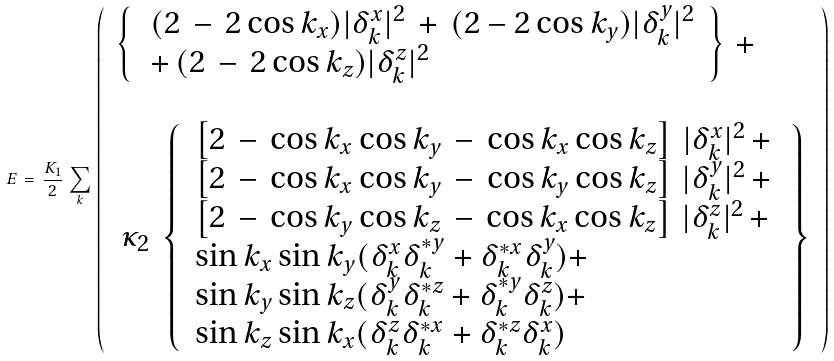Convert formula to latex. <formula><loc_0><loc_0><loc_500><loc_500>E \, = \, \frac { K _ { 1 } } { 2 } \, \sum _ { k } \, \left ( \, \begin{array} { l } \left \{ \, \begin{array} { l } \, ( 2 \, - \, 2 \cos k _ { x } ) | \delta _ { k } ^ { x } | ^ { 2 } \, + \, ( 2 - 2 \cos k _ { y } ) | \delta _ { k } ^ { y } | ^ { 2 } \\ \, + \, ( 2 \, - \, 2 \cos k _ { z } ) | \delta _ { k } ^ { z } | ^ { 2 } \end{array} \, \right \} \, + \, \\ \\ \, \kappa _ { 2 } \, \left \{ \, \begin{array} { l } \left [ 2 \, - \, \cos k _ { x } \cos k _ { y } \, - \, \cos k _ { x } \cos k _ { z } \right ] \, | \delta _ { k } ^ { x } | ^ { 2 } \, + \, \\ \left [ 2 \, - \, \cos k _ { x } \cos k _ { y } \, - \, \cos k _ { y } \cos k _ { z } \right ] \, | \delta _ { k } ^ { y } | ^ { 2 } \, + \, \\ \left [ 2 \, - \, \cos k _ { y } \cos k _ { z } \, - \, \cos k _ { x } \cos k _ { z } \right ] \, | \delta _ { k } ^ { z } | ^ { 2 } \, + \, \\ \sin k _ { x } \sin k _ { y } ( \delta _ { k } ^ { x } \delta _ { k } ^ { * y } + \delta _ { k } ^ { * x } \delta _ { k } ^ { y } ) + \\ \sin k _ { y } \sin k _ { z } ( \delta _ { k } ^ { y } \delta _ { k } ^ { * z } + \delta _ { k } ^ { * y } \delta _ { k } ^ { z } ) + \\ \sin k _ { z } \sin k _ { x } ( \delta _ { k } ^ { z } \delta _ { k } ^ { * x } + \delta _ { k } ^ { * z } \delta _ { k } ^ { x } ) \end{array} \, \right \} \end{array} \, \right )</formula> 